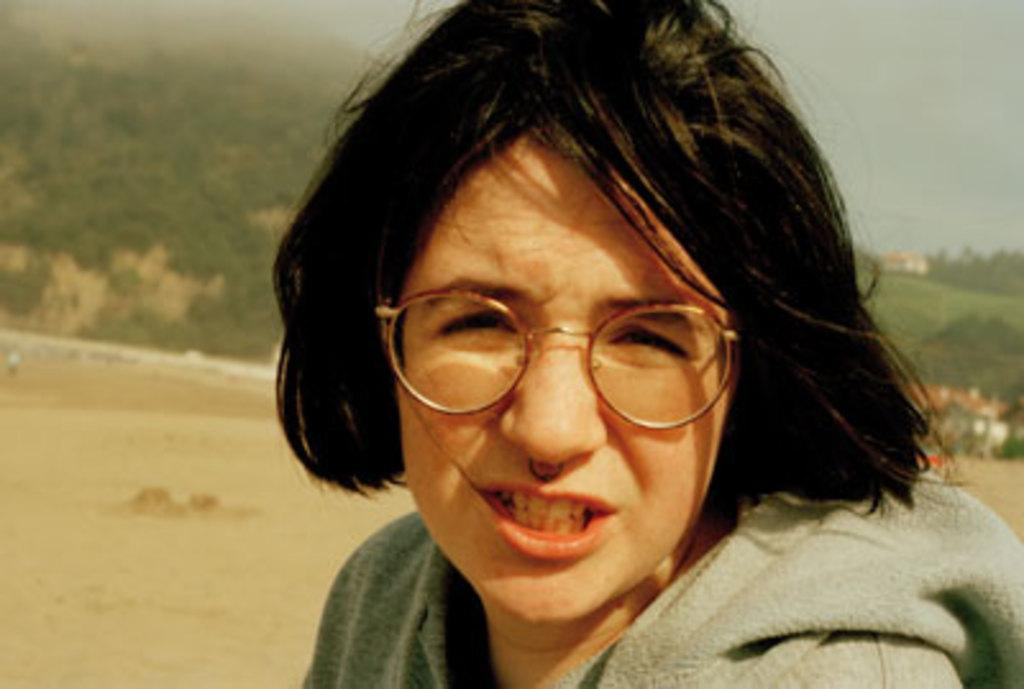Who is the main subject in the image? There is a lady in the image. What is the lady's position in the image? The lady is on the ground. What can be seen in the background of the image? There is a mountain in the background of the image. What team is the lady supporting in the image? There is no indication of a team or any sports-related activity in the image. 